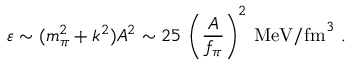Convert formula to latex. <formula><loc_0><loc_0><loc_500><loc_500>\varepsilon \sim ( m _ { \pi } ^ { 2 } + k ^ { 2 } ) A ^ { 2 } \sim 2 5 \ \left ( \frac { A } { f _ { \pi } } \right ) ^ { 2 } M e V / f m ^ { 3 } \ .</formula> 